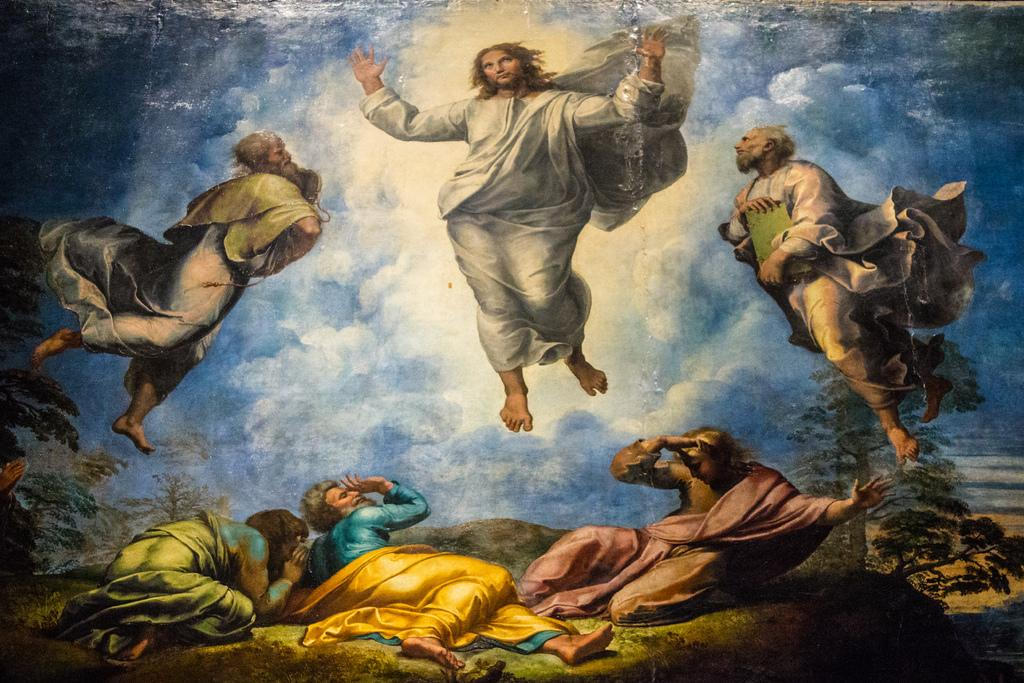What is the main subject of the image? The image contains a picture. What are the persons in the picture doing? Some persons are flying in the air, while others are lying on the ground. What can be seen in the background of the picture? There is a sky with clouds and trees in the background of the picture. Can you tell me how many snakes are slithering on the ground in the image? There are no snakes present in the image; the persons lying on the ground are the only subjects visible. What type of interest rate is being discussed in the image? There is no discussion of interest rates in the image; it features persons flying and lying on the ground, along with a sky and trees in the background. 